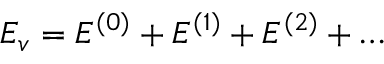<formula> <loc_0><loc_0><loc_500><loc_500>E _ { v } = E ^ { ( 0 ) } + E ^ { ( 1 ) } + E ^ { ( 2 ) } + \dots</formula> 